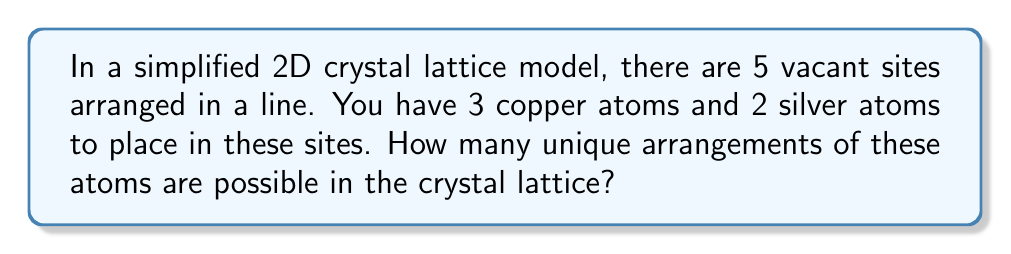Help me with this question. Let's approach this step-by-step:

1) This problem is a classic example of permutations with repetition.

2) We have 5 positions to fill, and two types of atoms:
   - 3 copper atoms (indistinguishable from each other)
   - 2 silver atoms (indistinguishable from each other)

3) The formula for permutations with repetition is:

   $$ \frac{n!}{n_1! \cdot n_2! \cdot ... \cdot n_k!} $$

   Where:
   $n$ is the total number of positions
   $n_1, n_2, ..., n_k$ are the numbers of each type of object

4) In our case:
   $n = 5$ (total positions)
   $n_1 = 3$ (copper atoms)
   $n_2 = 2$ (silver atoms)

5) Plugging into the formula:

   $$ \frac{5!}{3! \cdot 2!} $$

6) Calculating:
   $$ \frac{5 \cdot 4 \cdot 3 \cdot 2 \cdot 1}{(3 \cdot 2 \cdot 1) \cdot (2 \cdot 1)} $$
   
   $$ = \frac{120}{12} = 10 $$

Therefore, there are 10 unique arrangements possible.
Answer: 10 